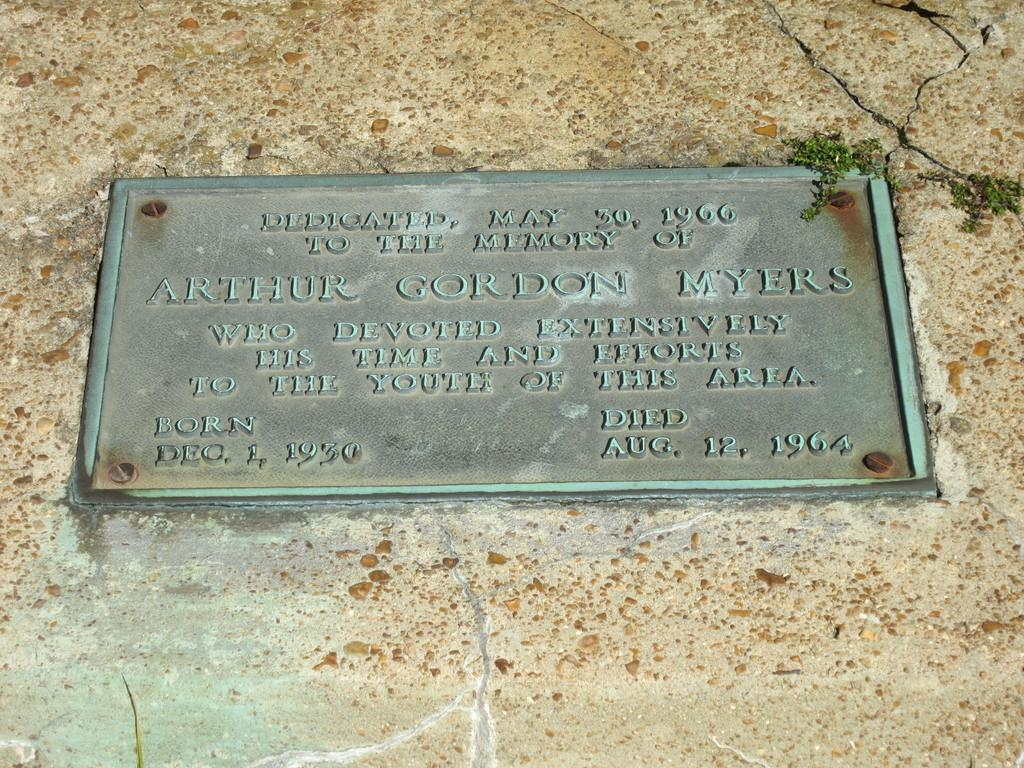What is attached to the wall in the image? There is a board fixed to the wall in the image. What is written or carved on the board? There are words carved on the board. What type of vegetation can be seen on the right side of the image? There are small plants on the right side of the image. Can you describe any imperfections or damage visible in the image? There is a crack visible in the image. How does the flock of birds interact with the lace in the image? There is no flock of birds or lace present in the image. 